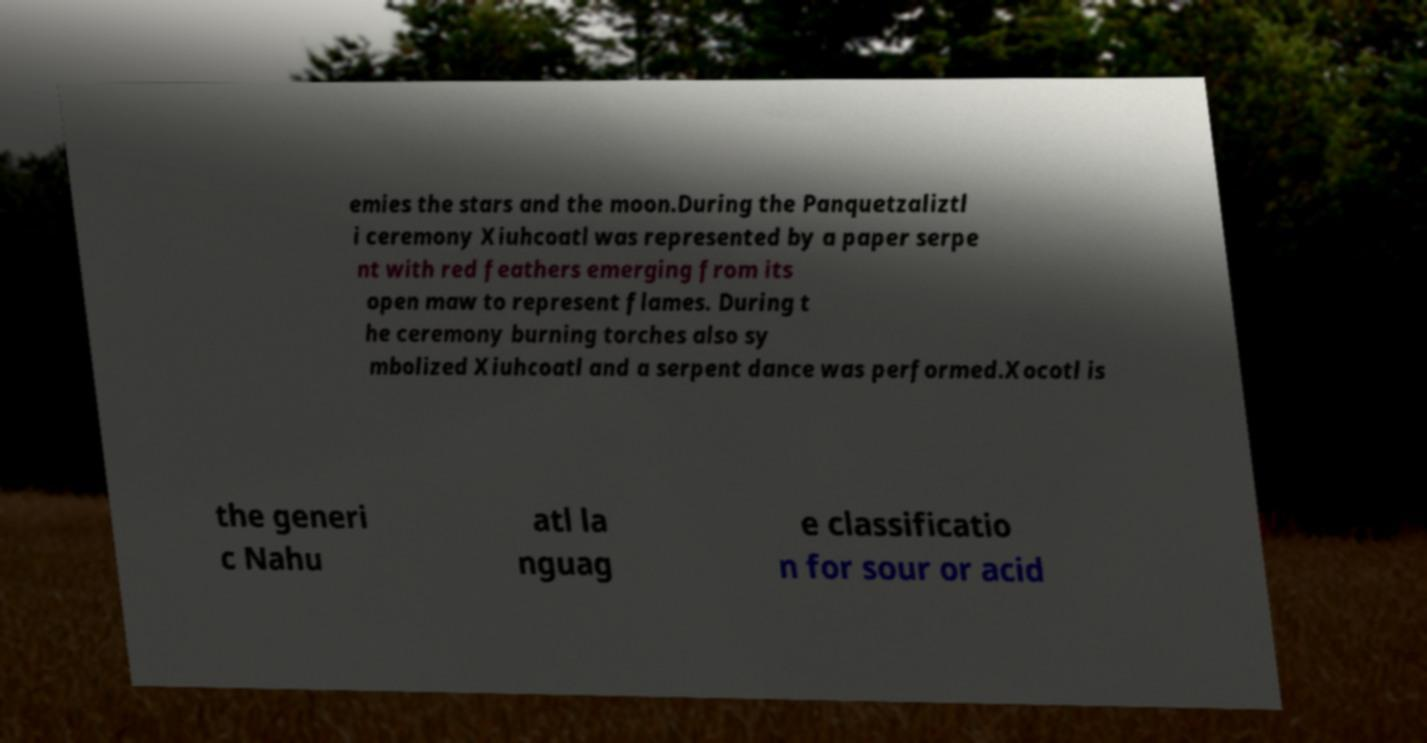Please read and relay the text visible in this image. What does it say? emies the stars and the moon.During the Panquetzaliztl i ceremony Xiuhcoatl was represented by a paper serpe nt with red feathers emerging from its open maw to represent flames. During t he ceremony burning torches also sy mbolized Xiuhcoatl and a serpent dance was performed.Xocotl is the generi c Nahu atl la nguag e classificatio n for sour or acid 